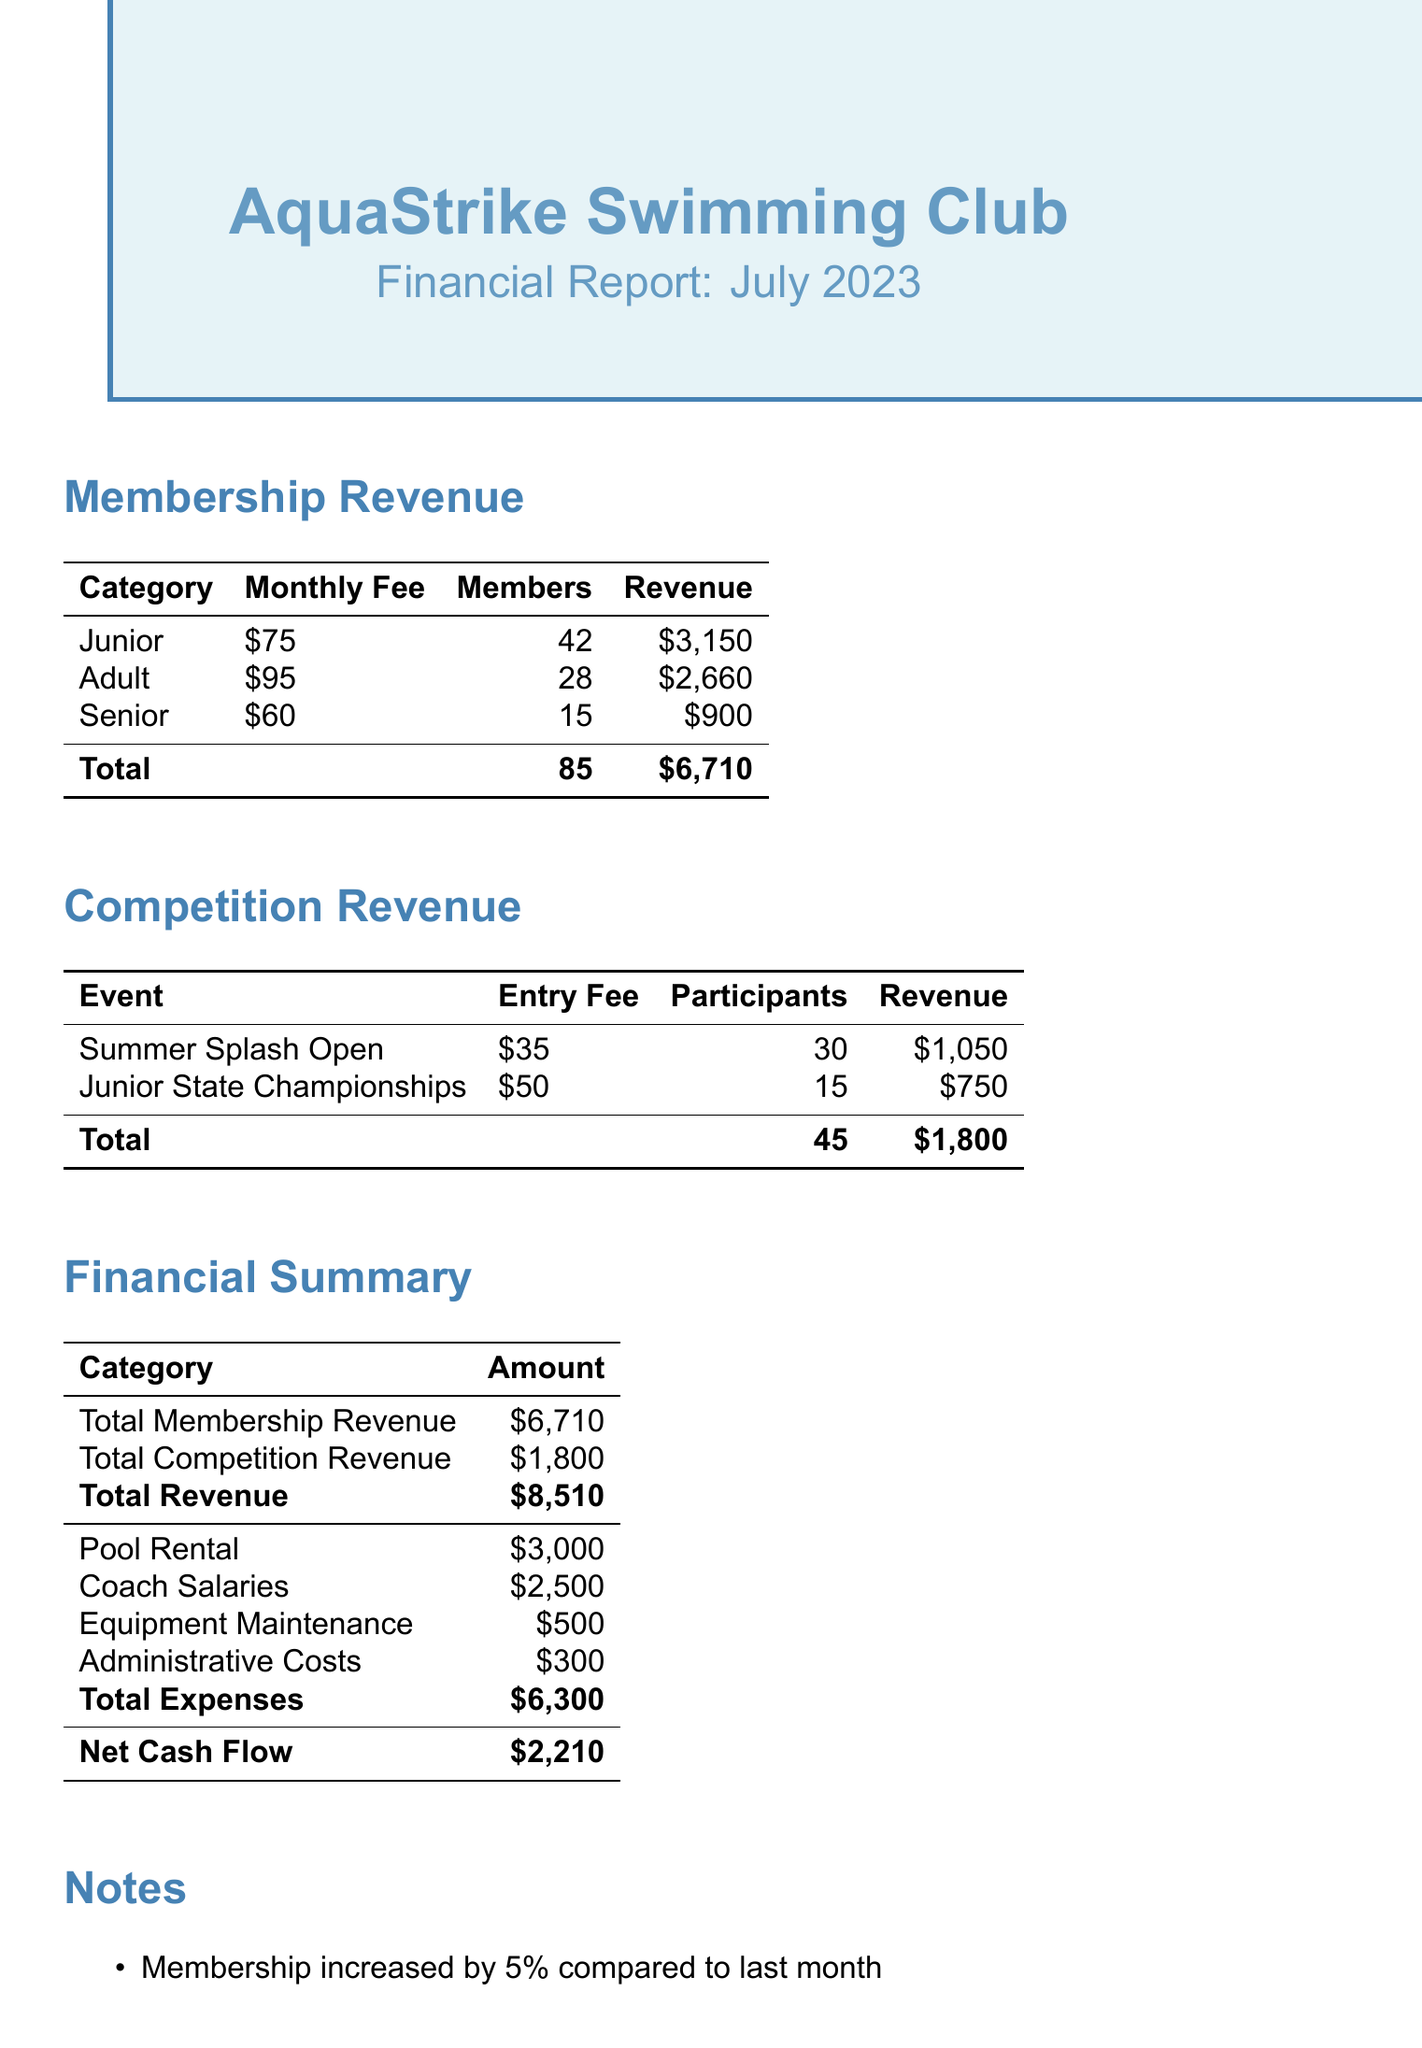what is the total membership revenue? The total membership revenue is listed as $6,710 in the financial summary.
Answer: $6,710 how many junior members are there? The document states there are 42 junior members contributing to the membership fees.
Answer: 42 what was the entry fee for the Junior State Championships? The document shows the entry fee for the Junior State Championships is $50.
Answer: $50 what is the net cash flow for July 2023? The net cash flow is calculated as total revenue minus total expenses, and it is stated as $2,210.
Answer: $2,210 what percentage did membership increase compared to last month? The notes indicate that membership increased by 5% compared to last month.
Answer: 5% what was the total revenue from competition entries? The total revenue from competition entries is $1,800, as per the financial summary.
Answer: $1,800 how many participants took part in the Summer Splash Open? The document mentions that there were 30 participants in the Summer Splash Open.
Answer: 30 what is one recommendation mentioned in the notes? One recommendation in the notes suggests considering raising adult membership fees next quarter.
Answer: Raising adult membership fees what are the total expenses listed in the document? The total expenses combine all costs and are listed as $6,300 in the financial summary.
Answer: $6,300 